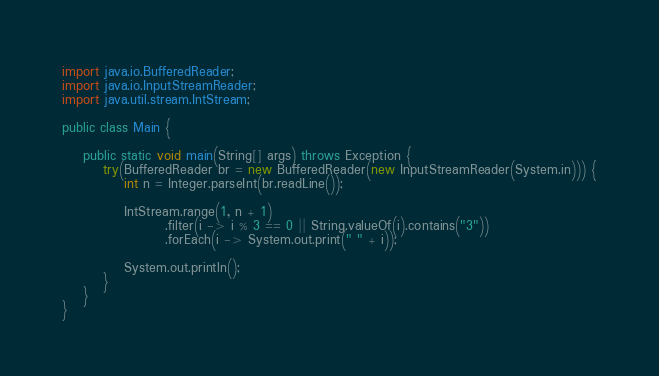Convert code to text. <code><loc_0><loc_0><loc_500><loc_500><_Java_>import java.io.BufferedReader;
import java.io.InputStreamReader;
import java.util.stream.IntStream;

public class Main {

    public static void main(String[] args) throws Exception {
        try(BufferedReader br = new BufferedReader(new InputStreamReader(System.in))) {
            int n = Integer.parseInt(br.readLine());

            IntStream.range(1, n + 1)
                    .filter(i -> i % 3 == 0 || String.valueOf(i).contains("3"))
                    .forEach(i -> System.out.print(" " + i));

            System.out.println();
        }
    }
}</code> 